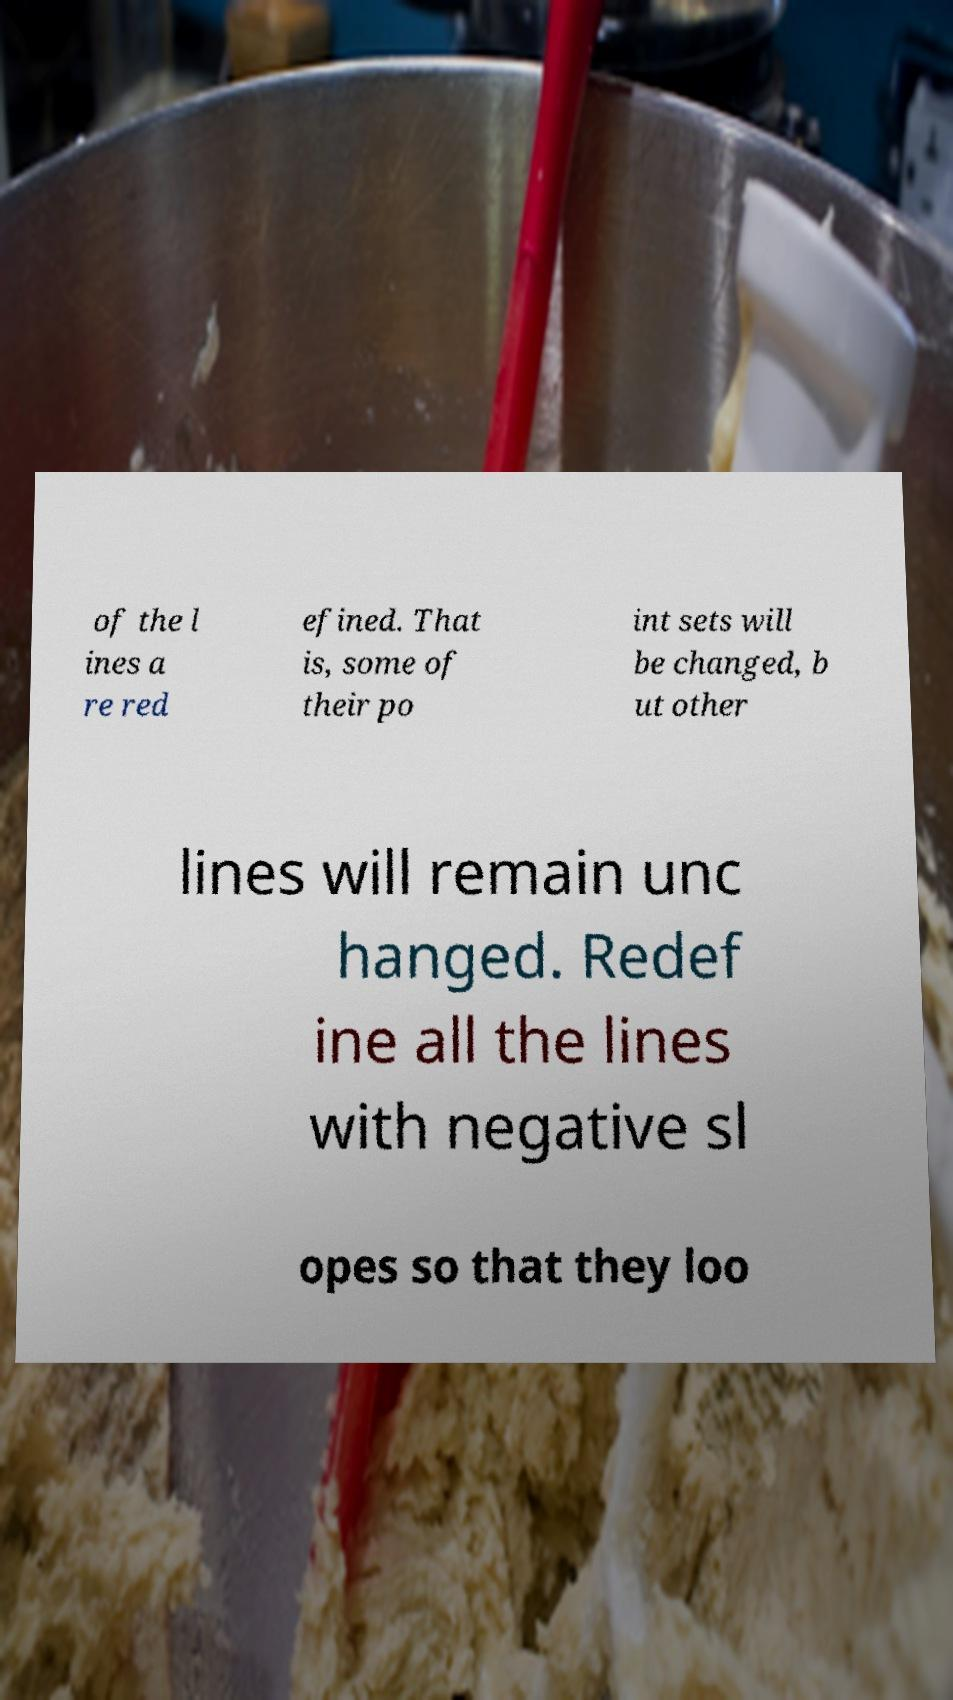Please read and relay the text visible in this image. What does it say? of the l ines a re red efined. That is, some of their po int sets will be changed, b ut other lines will remain unc hanged. Redef ine all the lines with negative sl opes so that they loo 